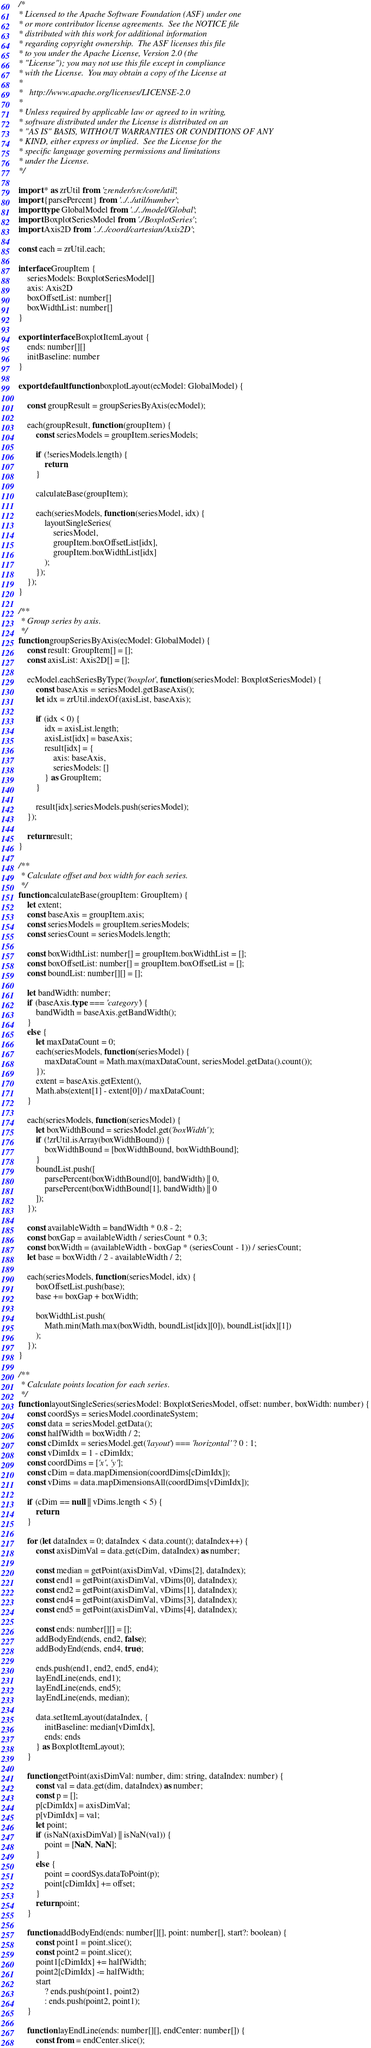Convert code to text. <code><loc_0><loc_0><loc_500><loc_500><_TypeScript_>/*
* Licensed to the Apache Software Foundation (ASF) under one
* or more contributor license agreements.  See the NOTICE file
* distributed with this work for additional information
* regarding copyright ownership.  The ASF licenses this file
* to you under the Apache License, Version 2.0 (the
* "License"); you may not use this file except in compliance
* with the License.  You may obtain a copy of the License at
*
*   http://www.apache.org/licenses/LICENSE-2.0
*
* Unless required by applicable law or agreed to in writing,
* software distributed under the License is distributed on an
* "AS IS" BASIS, WITHOUT WARRANTIES OR CONDITIONS OF ANY
* KIND, either express or implied.  See the License for the
* specific language governing permissions and limitations
* under the License.
*/

import * as zrUtil from 'zrender/src/core/util';
import {parsePercent} from '../../util/number';
import type GlobalModel from '../../model/Global';
import BoxplotSeriesModel from './BoxplotSeries';
import Axis2D from '../../coord/cartesian/Axis2D';

const each = zrUtil.each;

interface GroupItem {
    seriesModels: BoxplotSeriesModel[]
    axis: Axis2D
    boxOffsetList: number[]
    boxWidthList: number[]
}

export interface BoxplotItemLayout {
    ends: number[][]
    initBaseline: number
}

export default function boxplotLayout(ecModel: GlobalModel) {

    const groupResult = groupSeriesByAxis(ecModel);

    each(groupResult, function (groupItem) {
        const seriesModels = groupItem.seriesModels;

        if (!seriesModels.length) {
            return;
        }

        calculateBase(groupItem);

        each(seriesModels, function (seriesModel, idx) {
            layoutSingleSeries(
                seriesModel,
                groupItem.boxOffsetList[idx],
                groupItem.boxWidthList[idx]
            );
        });
    });
}

/**
 * Group series by axis.
 */
function groupSeriesByAxis(ecModel: GlobalModel) {
    const result: GroupItem[] = [];
    const axisList: Axis2D[] = [];

    ecModel.eachSeriesByType('boxplot', function (seriesModel: BoxplotSeriesModel) {
        const baseAxis = seriesModel.getBaseAxis();
        let idx = zrUtil.indexOf(axisList, baseAxis);

        if (idx < 0) {
            idx = axisList.length;
            axisList[idx] = baseAxis;
            result[idx] = {
                axis: baseAxis,
                seriesModels: []
            } as GroupItem;
        }

        result[idx].seriesModels.push(seriesModel);
    });

    return result;
}

/**
 * Calculate offset and box width for each series.
 */
function calculateBase(groupItem: GroupItem) {
    let extent;
    const baseAxis = groupItem.axis;
    const seriesModels = groupItem.seriesModels;
    const seriesCount = seriesModels.length;

    const boxWidthList: number[] = groupItem.boxWidthList = [];
    const boxOffsetList: number[] = groupItem.boxOffsetList = [];
    const boundList: number[][] = [];

    let bandWidth: number;
    if (baseAxis.type === 'category') {
        bandWidth = baseAxis.getBandWidth();
    }
    else {
        let maxDataCount = 0;
        each(seriesModels, function (seriesModel) {
            maxDataCount = Math.max(maxDataCount, seriesModel.getData().count());
        });
        extent = baseAxis.getExtent(),
        Math.abs(extent[1] - extent[0]) / maxDataCount;
    }

    each(seriesModels, function (seriesModel) {
        let boxWidthBound = seriesModel.get('boxWidth');
        if (!zrUtil.isArray(boxWidthBound)) {
            boxWidthBound = [boxWidthBound, boxWidthBound];
        }
        boundList.push([
            parsePercent(boxWidthBound[0], bandWidth) || 0,
            parsePercent(boxWidthBound[1], bandWidth) || 0
        ]);
    });

    const availableWidth = bandWidth * 0.8 - 2;
    const boxGap = availableWidth / seriesCount * 0.3;
    const boxWidth = (availableWidth - boxGap * (seriesCount - 1)) / seriesCount;
    let base = boxWidth / 2 - availableWidth / 2;

    each(seriesModels, function (seriesModel, idx) {
        boxOffsetList.push(base);
        base += boxGap + boxWidth;

        boxWidthList.push(
            Math.min(Math.max(boxWidth, boundList[idx][0]), boundList[idx][1])
        );
    });
}

/**
 * Calculate points location for each series.
 */
function layoutSingleSeries(seriesModel: BoxplotSeriesModel, offset: number, boxWidth: number) {
    const coordSys = seriesModel.coordinateSystem;
    const data = seriesModel.getData();
    const halfWidth = boxWidth / 2;
    const cDimIdx = seriesModel.get('layout') === 'horizontal' ? 0 : 1;
    const vDimIdx = 1 - cDimIdx;
    const coordDims = ['x', 'y'];
    const cDim = data.mapDimension(coordDims[cDimIdx]);
    const vDims = data.mapDimensionsAll(coordDims[vDimIdx]);

    if (cDim == null || vDims.length < 5) {
        return;
    }

    for (let dataIndex = 0; dataIndex < data.count(); dataIndex++) {
        const axisDimVal = data.get(cDim, dataIndex) as number;

        const median = getPoint(axisDimVal, vDims[2], dataIndex);
        const end1 = getPoint(axisDimVal, vDims[0], dataIndex);
        const end2 = getPoint(axisDimVal, vDims[1], dataIndex);
        const end4 = getPoint(axisDimVal, vDims[3], dataIndex);
        const end5 = getPoint(axisDimVal, vDims[4], dataIndex);

        const ends: number[][] = [];
        addBodyEnd(ends, end2, false);
        addBodyEnd(ends, end4, true);

        ends.push(end1, end2, end5, end4);
        layEndLine(ends, end1);
        layEndLine(ends, end5);
        layEndLine(ends, median);

        data.setItemLayout(dataIndex, {
            initBaseline: median[vDimIdx],
            ends: ends
        } as BoxplotItemLayout);
    }

    function getPoint(axisDimVal: number, dim: string, dataIndex: number) {
        const val = data.get(dim, dataIndex) as number;
        const p = [];
        p[cDimIdx] = axisDimVal;
        p[vDimIdx] = val;
        let point;
        if (isNaN(axisDimVal) || isNaN(val)) {
            point = [NaN, NaN];
        }
        else {
            point = coordSys.dataToPoint(p);
            point[cDimIdx] += offset;
        }
        return point;
    }

    function addBodyEnd(ends: number[][], point: number[], start?: boolean) {
        const point1 = point.slice();
        const point2 = point.slice();
        point1[cDimIdx] += halfWidth;
        point2[cDimIdx] -= halfWidth;
        start
            ? ends.push(point1, point2)
            : ends.push(point2, point1);
    }

    function layEndLine(ends: number[][], endCenter: number[]) {
        const from = endCenter.slice();</code> 